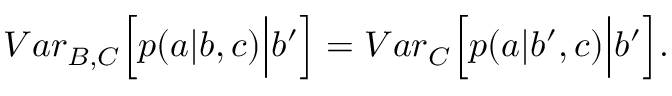Convert formula to latex. <formula><loc_0><loc_0><loc_500><loc_500>{ V a r } _ { B , C } \left [ p ( a | b , c ) \left | b ^ { \prime } \right ] = { V a r } _ { C } \left [ p ( a | b ^ { \prime } , c ) \right | b ^ { \prime } \right ] .</formula> 